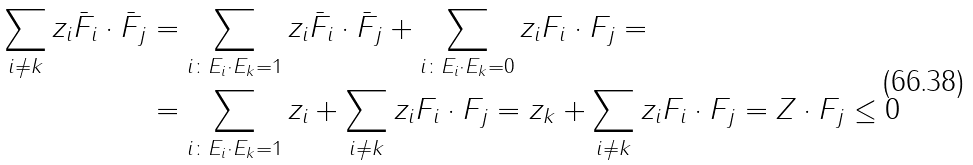Convert formula to latex. <formula><loc_0><loc_0><loc_500><loc_500>\sum _ { i \ne k } z _ { i } \bar { F } _ { i } \cdot \bar { F } _ { j } & = \sum _ { i \colon E _ { i } \cdot E _ { k } = 1 } z _ { i } \bar { F } _ { i } \cdot \bar { F } _ { j } + \sum _ { i \colon E _ { i } \cdot E _ { k } = 0 } z _ { i } F _ { i } \cdot F _ { j } = \\ & = \sum _ { i \colon E _ { i } \cdot E _ { k } = 1 } z _ { i } + \sum _ { i \ne k } z _ { i } F _ { i } \cdot F _ { j } = z _ { k } + \sum _ { i \ne k } z _ { i } F _ { i } \cdot F _ { j } = Z \cdot F _ { j } \leq 0</formula> 